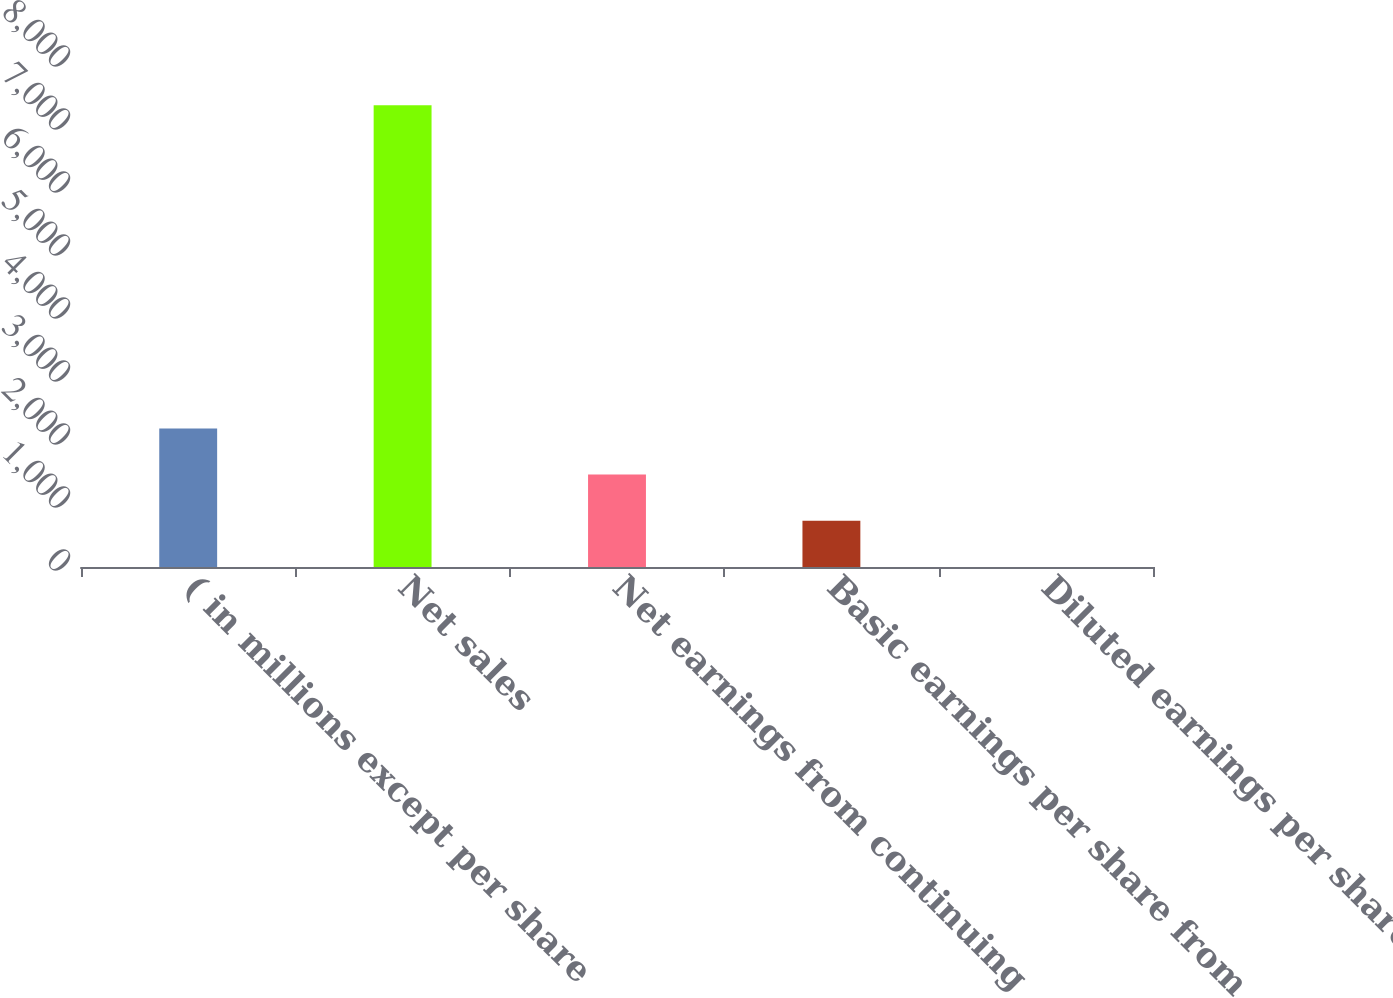Convert chart. <chart><loc_0><loc_0><loc_500><loc_500><bar_chart><fcel>( in millions except per share<fcel>Net sales<fcel>Net earnings from continuing<fcel>Basic earnings per share from<fcel>Diluted earnings per share<nl><fcel>2200.18<fcel>7330.1<fcel>1467.34<fcel>734.5<fcel>1.66<nl></chart> 